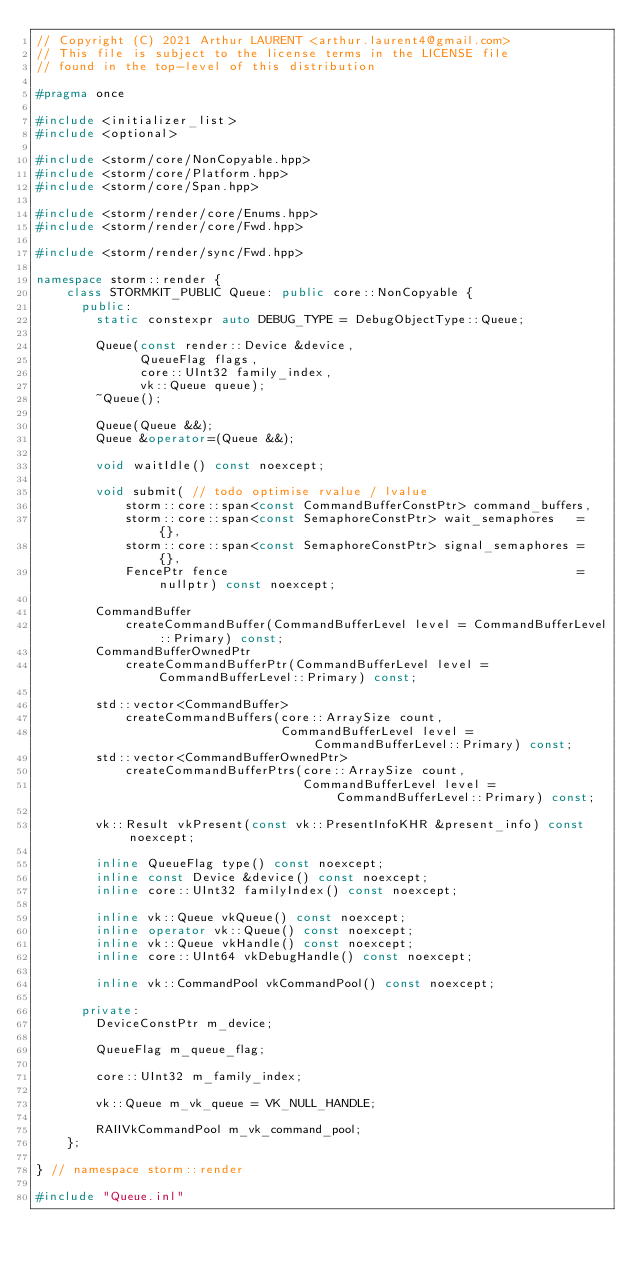Convert code to text. <code><loc_0><loc_0><loc_500><loc_500><_C++_>// Copyright (C) 2021 Arthur LAURENT <arthur.laurent4@gmail.com>
// This file is subject to the license terms in the LICENSE file
// found in the top-level of this distribution

#pragma once

#include <initializer_list>
#include <optional>

#include <storm/core/NonCopyable.hpp>
#include <storm/core/Platform.hpp>
#include <storm/core/Span.hpp>

#include <storm/render/core/Enums.hpp>
#include <storm/render/core/Fwd.hpp>

#include <storm/render/sync/Fwd.hpp>

namespace storm::render {
    class STORMKIT_PUBLIC Queue: public core::NonCopyable {
      public:
        static constexpr auto DEBUG_TYPE = DebugObjectType::Queue;

        Queue(const render::Device &device,
              QueueFlag flags,
              core::UInt32 family_index,
              vk::Queue queue);
        ~Queue();

        Queue(Queue &&);
        Queue &operator=(Queue &&);

        void waitIdle() const noexcept;

        void submit( // todo optimise rvalue / lvalue
            storm::core::span<const CommandBufferConstPtr> command_buffers,
            storm::core::span<const SemaphoreConstPtr> wait_semaphores   = {},
            storm::core::span<const SemaphoreConstPtr> signal_semaphores = {},
            FencePtr fence                                               = nullptr) const noexcept;

        CommandBuffer
            createCommandBuffer(CommandBufferLevel level = CommandBufferLevel::Primary) const;
        CommandBufferOwnedPtr
            createCommandBufferPtr(CommandBufferLevel level = CommandBufferLevel::Primary) const;

        std::vector<CommandBuffer>
            createCommandBuffers(core::ArraySize count,
                                 CommandBufferLevel level = CommandBufferLevel::Primary) const;
        std::vector<CommandBufferOwnedPtr>
            createCommandBufferPtrs(core::ArraySize count,
                                    CommandBufferLevel level = CommandBufferLevel::Primary) const;

        vk::Result vkPresent(const vk::PresentInfoKHR &present_info) const noexcept;

        inline QueueFlag type() const noexcept;
        inline const Device &device() const noexcept;
        inline core::UInt32 familyIndex() const noexcept;

        inline vk::Queue vkQueue() const noexcept;
        inline operator vk::Queue() const noexcept;
        inline vk::Queue vkHandle() const noexcept;
        inline core::UInt64 vkDebugHandle() const noexcept;

        inline vk::CommandPool vkCommandPool() const noexcept;

      private:
        DeviceConstPtr m_device;

        QueueFlag m_queue_flag;

        core::UInt32 m_family_index;

        vk::Queue m_vk_queue = VK_NULL_HANDLE;

        RAIIVkCommandPool m_vk_command_pool;
    };

} // namespace storm::render

#include "Queue.inl"
</code> 